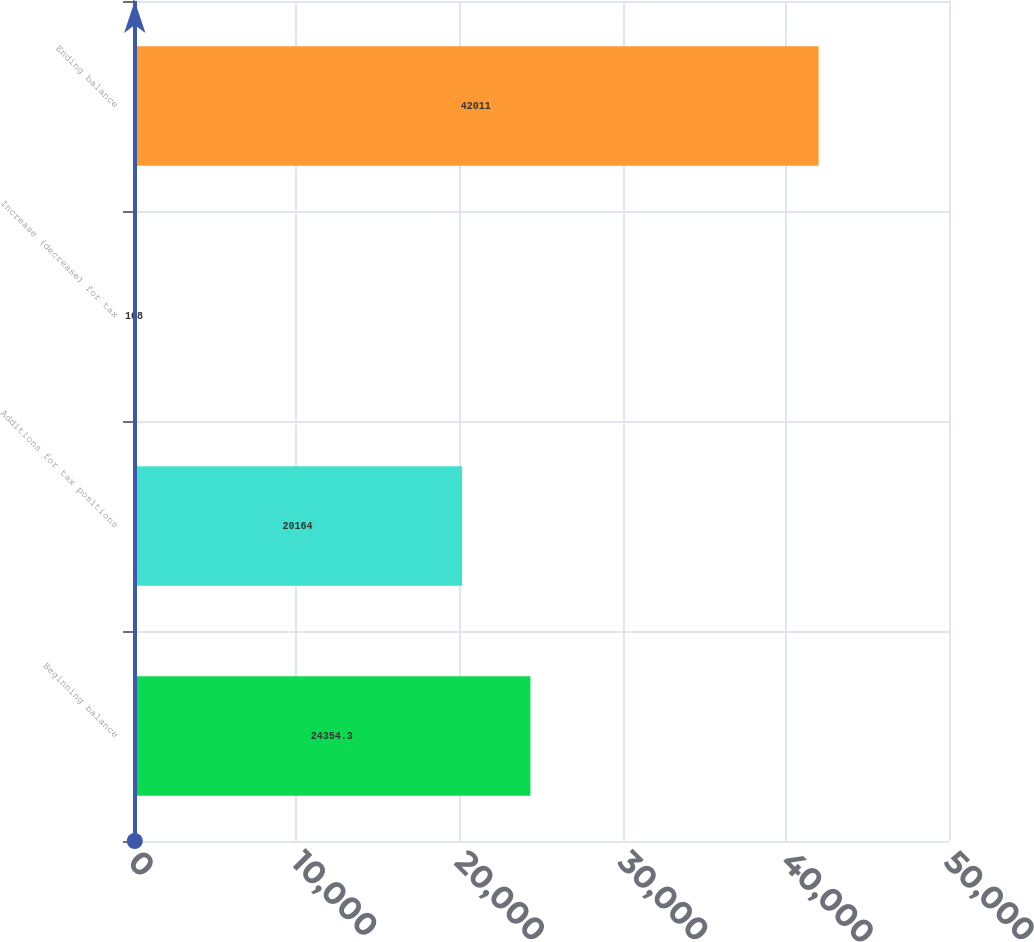Convert chart to OTSL. <chart><loc_0><loc_0><loc_500><loc_500><bar_chart><fcel>Beginning balance<fcel>Additions for tax positions<fcel>Increase (decrease) for tax<fcel>Ending balance<nl><fcel>24354.3<fcel>20164<fcel>108<fcel>42011<nl></chart> 